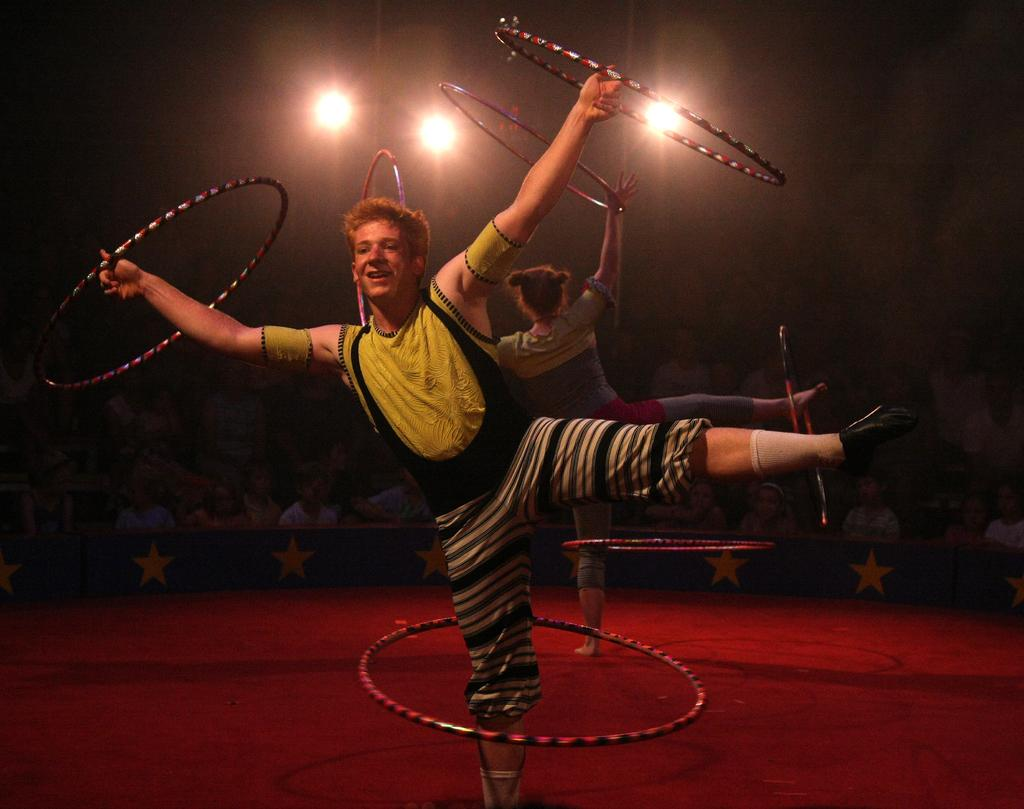Who are the main subjects in the image? There is a boy and a girl in the image. What are they doing in the image? They are performing gymnastics on the stage. What type of equipment is being used for their performance? The gymnastics equipment includes rings. Who is observing the performance? There are people seated and watching the performance. What can be seen in the image that provides illumination? There are lights visible in the image. What type of underwear is the boy wearing during his gymnastics performance? There is no information about the boy's underwear in the image, and it is not appropriate to make assumptions about someone's clothing based on a photograph. What is the range of the gymnastics equipment in the image? The provided facts do not include information about the range of the gymnastics equipment, so it cannot be determined from the image. 